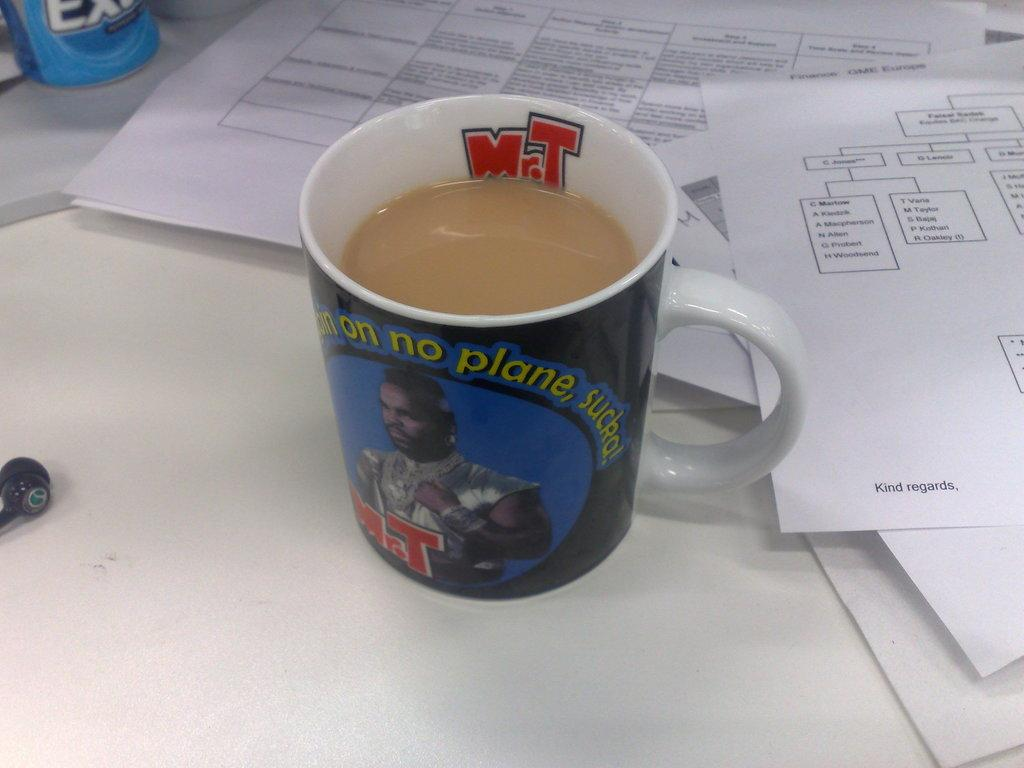What is in the mug that is visible in the image? The mug contains a liquid in brown color. What else can be seen on the table in the image? There are papers on the table in the background. What is the color of the table in the image? The table is white. Is the person in the image driving a car? There is no person visible in the image, and therefore no indication of driving a car. How many yams are present on the table in the image? There are no yams present in the image. 